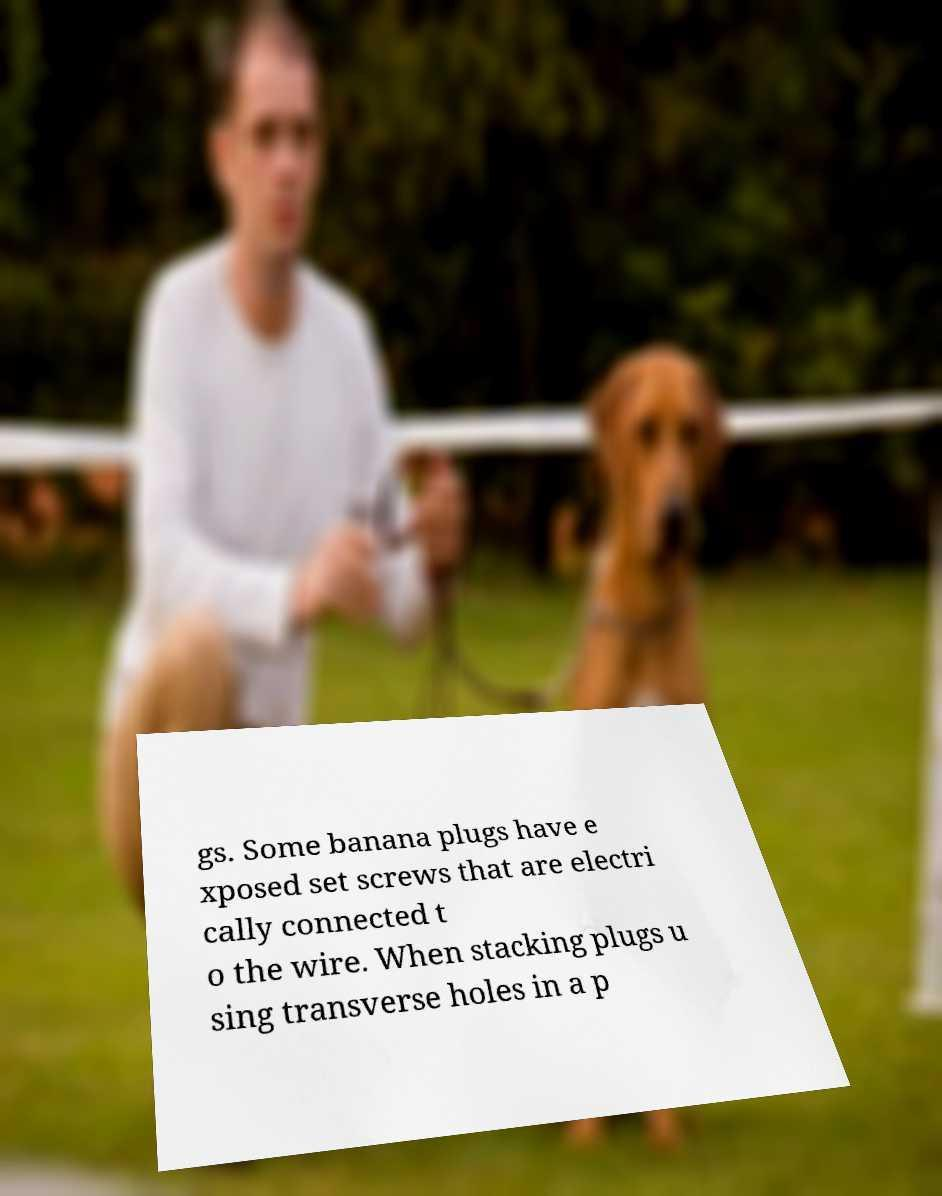Please identify and transcribe the text found in this image. gs. Some banana plugs have e xposed set screws that are electri cally connected t o the wire. When stacking plugs u sing transverse holes in a p 